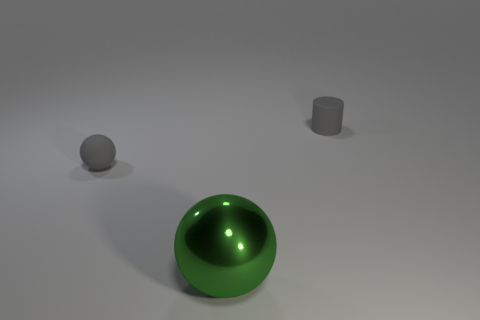Subtract all blue cylinders. Subtract all brown spheres. How many cylinders are left? 1 Add 3 green objects. How many objects exist? 6 Subtract all cylinders. How many objects are left? 2 Add 3 tiny gray rubber things. How many tiny gray rubber things exist? 5 Subtract 0 red spheres. How many objects are left? 3 Subtract all metal balls. Subtract all big purple matte cylinders. How many objects are left? 2 Add 2 spheres. How many spheres are left? 4 